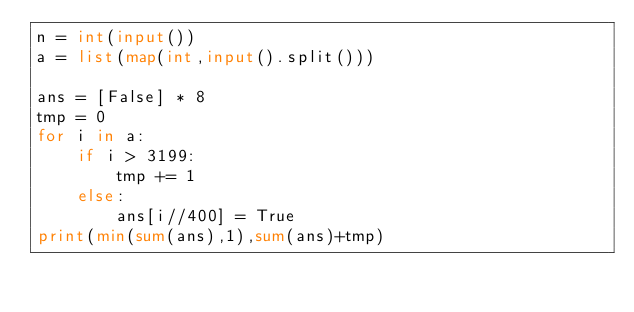<code> <loc_0><loc_0><loc_500><loc_500><_Python_>n = int(input())
a = list(map(int,input().split()))

ans = [False] * 8
tmp = 0
for i in a:
    if i > 3199:
        tmp += 1
    else:
        ans[i//400] = True
print(min(sum(ans),1),sum(ans)+tmp)</code> 